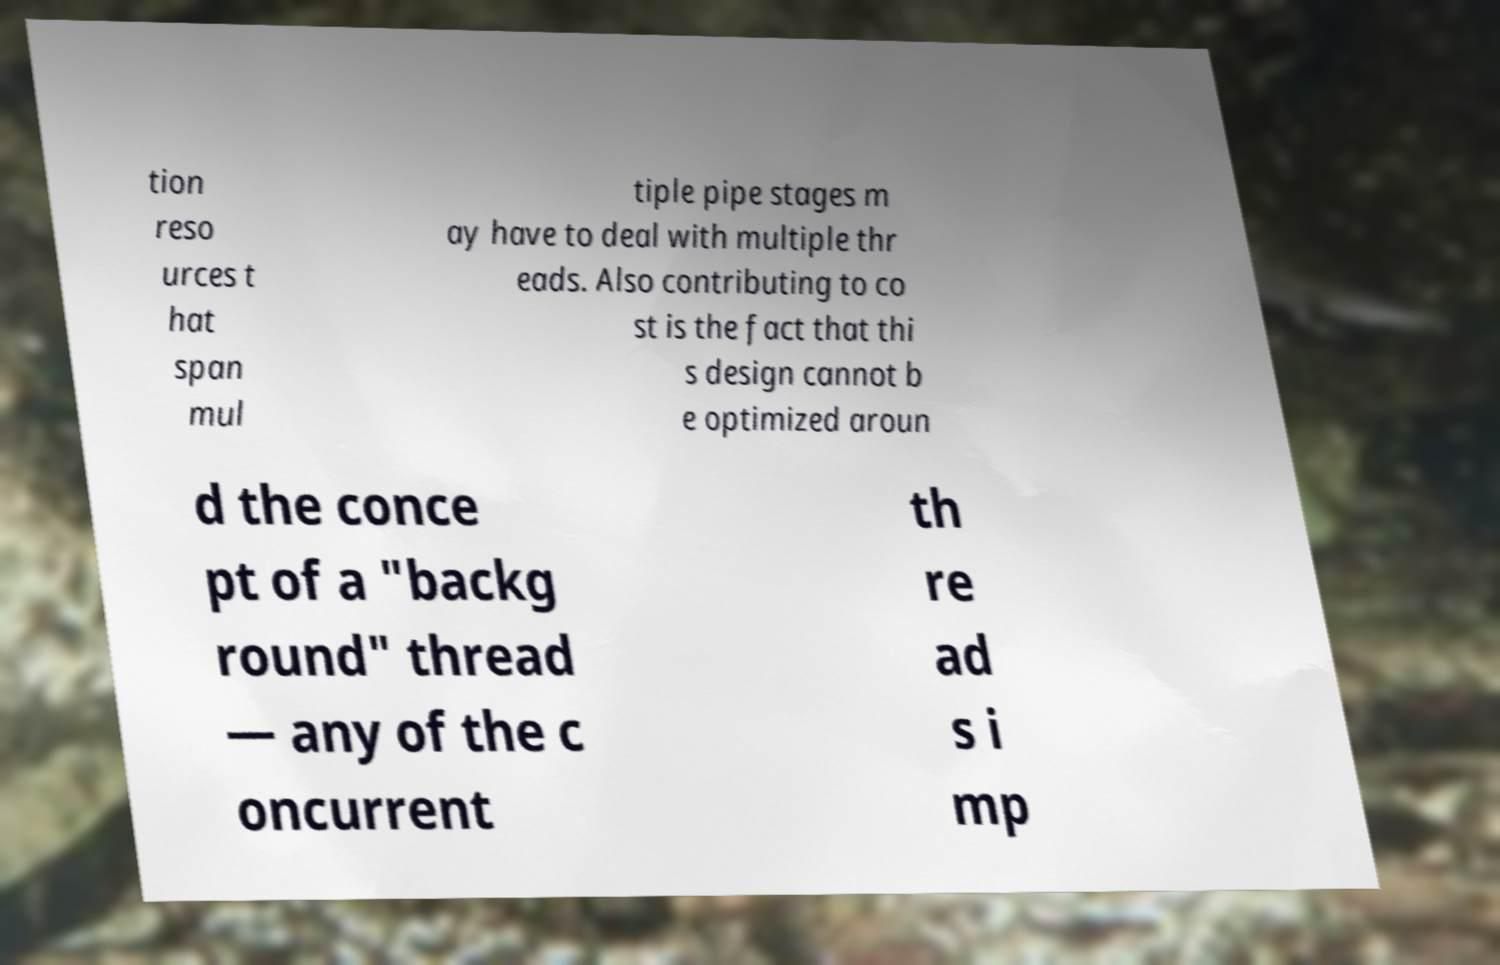What messages or text are displayed in this image? I need them in a readable, typed format. tion reso urces t hat span mul tiple pipe stages m ay have to deal with multiple thr eads. Also contributing to co st is the fact that thi s design cannot b e optimized aroun d the conce pt of a "backg round" thread — any of the c oncurrent th re ad s i mp 